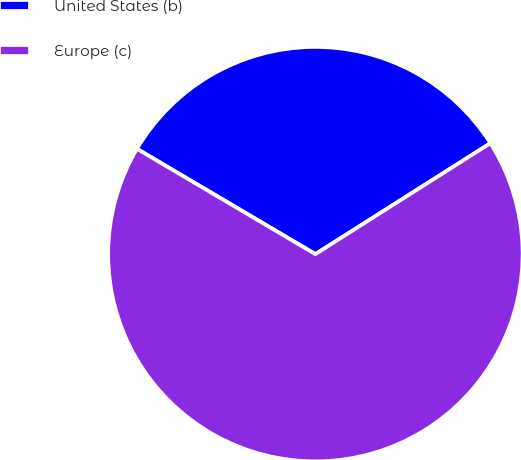<chart> <loc_0><loc_0><loc_500><loc_500><pie_chart><fcel>United States (b)<fcel>Europe (c)<nl><fcel>32.52%<fcel>67.48%<nl></chart> 